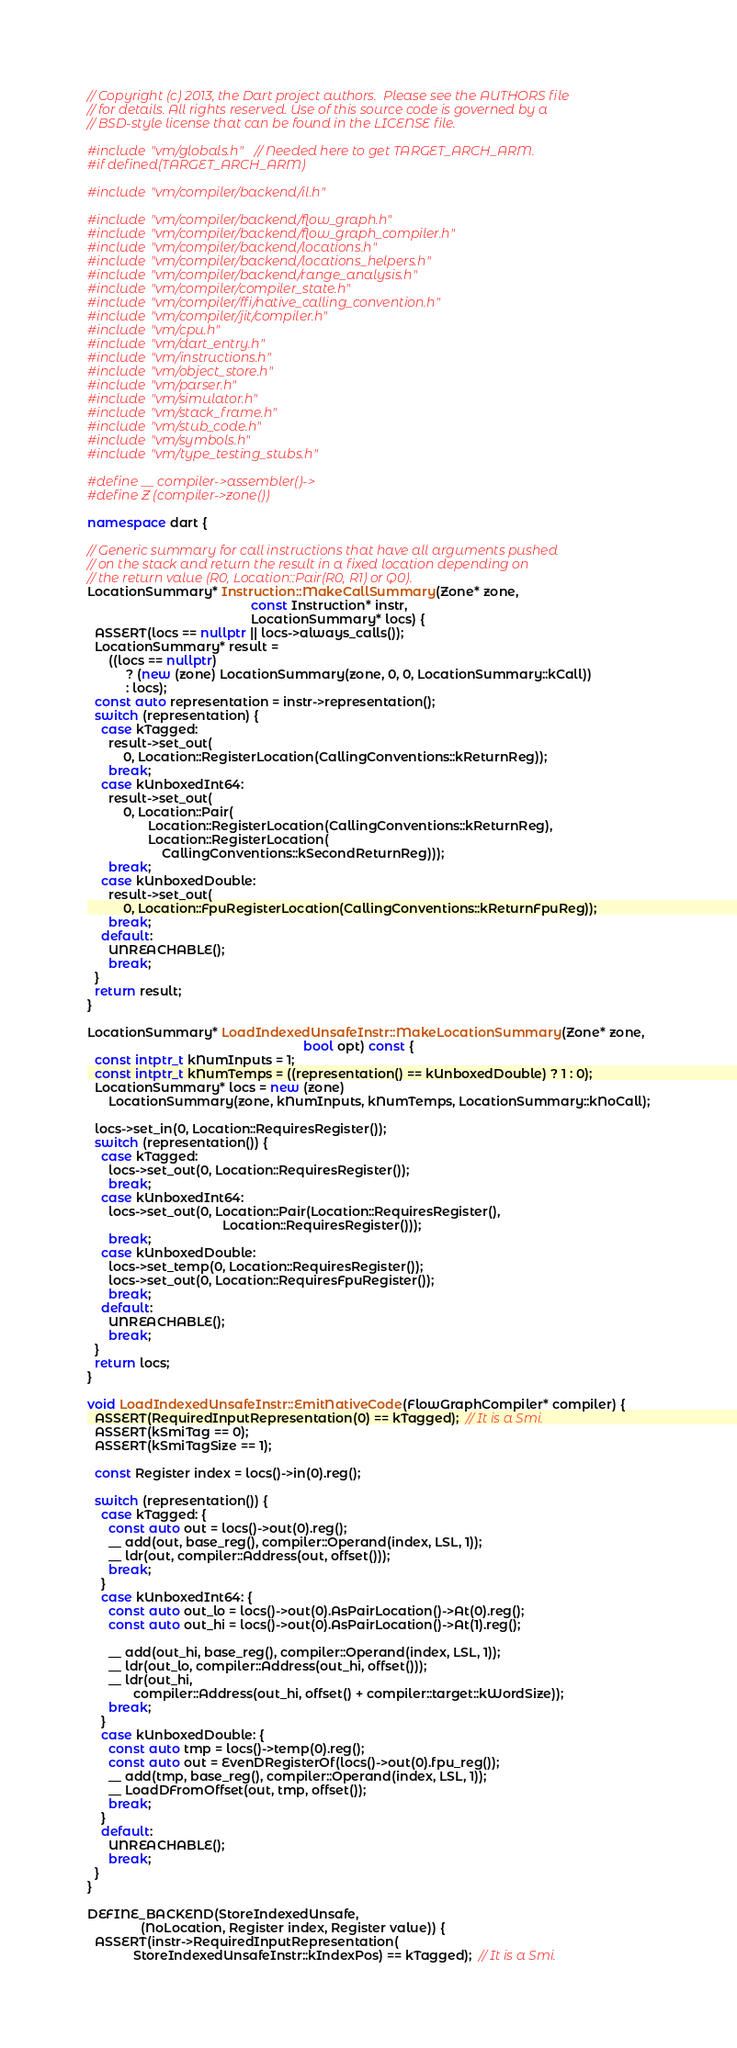<code> <loc_0><loc_0><loc_500><loc_500><_C++_>// Copyright (c) 2013, the Dart project authors.  Please see the AUTHORS file
// for details. All rights reserved. Use of this source code is governed by a
// BSD-style license that can be found in the LICENSE file.

#include "vm/globals.h"  // Needed here to get TARGET_ARCH_ARM.
#if defined(TARGET_ARCH_ARM)

#include "vm/compiler/backend/il.h"

#include "vm/compiler/backend/flow_graph.h"
#include "vm/compiler/backend/flow_graph_compiler.h"
#include "vm/compiler/backend/locations.h"
#include "vm/compiler/backend/locations_helpers.h"
#include "vm/compiler/backend/range_analysis.h"
#include "vm/compiler/compiler_state.h"
#include "vm/compiler/ffi/native_calling_convention.h"
#include "vm/compiler/jit/compiler.h"
#include "vm/cpu.h"
#include "vm/dart_entry.h"
#include "vm/instructions.h"
#include "vm/object_store.h"
#include "vm/parser.h"
#include "vm/simulator.h"
#include "vm/stack_frame.h"
#include "vm/stub_code.h"
#include "vm/symbols.h"
#include "vm/type_testing_stubs.h"

#define __ compiler->assembler()->
#define Z (compiler->zone())

namespace dart {

// Generic summary for call instructions that have all arguments pushed
// on the stack and return the result in a fixed location depending on
// the return value (R0, Location::Pair(R0, R1) or Q0).
LocationSummary* Instruction::MakeCallSummary(Zone* zone,
                                              const Instruction* instr,
                                              LocationSummary* locs) {
  ASSERT(locs == nullptr || locs->always_calls());
  LocationSummary* result =
      ((locs == nullptr)
           ? (new (zone) LocationSummary(zone, 0, 0, LocationSummary::kCall))
           : locs);
  const auto representation = instr->representation();
  switch (representation) {
    case kTagged:
      result->set_out(
          0, Location::RegisterLocation(CallingConventions::kReturnReg));
      break;
    case kUnboxedInt64:
      result->set_out(
          0, Location::Pair(
                 Location::RegisterLocation(CallingConventions::kReturnReg),
                 Location::RegisterLocation(
                     CallingConventions::kSecondReturnReg)));
      break;
    case kUnboxedDouble:
      result->set_out(
          0, Location::FpuRegisterLocation(CallingConventions::kReturnFpuReg));
      break;
    default:
      UNREACHABLE();
      break;
  }
  return result;
}

LocationSummary* LoadIndexedUnsafeInstr::MakeLocationSummary(Zone* zone,
                                                             bool opt) const {
  const intptr_t kNumInputs = 1;
  const intptr_t kNumTemps = ((representation() == kUnboxedDouble) ? 1 : 0);
  LocationSummary* locs = new (zone)
      LocationSummary(zone, kNumInputs, kNumTemps, LocationSummary::kNoCall);

  locs->set_in(0, Location::RequiresRegister());
  switch (representation()) {
    case kTagged:
      locs->set_out(0, Location::RequiresRegister());
      break;
    case kUnboxedInt64:
      locs->set_out(0, Location::Pair(Location::RequiresRegister(),
                                      Location::RequiresRegister()));
      break;
    case kUnboxedDouble:
      locs->set_temp(0, Location::RequiresRegister());
      locs->set_out(0, Location::RequiresFpuRegister());
      break;
    default:
      UNREACHABLE();
      break;
  }
  return locs;
}

void LoadIndexedUnsafeInstr::EmitNativeCode(FlowGraphCompiler* compiler) {
  ASSERT(RequiredInputRepresentation(0) == kTagged);  // It is a Smi.
  ASSERT(kSmiTag == 0);
  ASSERT(kSmiTagSize == 1);

  const Register index = locs()->in(0).reg();

  switch (representation()) {
    case kTagged: {
      const auto out = locs()->out(0).reg();
      __ add(out, base_reg(), compiler::Operand(index, LSL, 1));
      __ ldr(out, compiler::Address(out, offset()));
      break;
    }
    case kUnboxedInt64: {
      const auto out_lo = locs()->out(0).AsPairLocation()->At(0).reg();
      const auto out_hi = locs()->out(0).AsPairLocation()->At(1).reg();

      __ add(out_hi, base_reg(), compiler::Operand(index, LSL, 1));
      __ ldr(out_lo, compiler::Address(out_hi, offset()));
      __ ldr(out_hi,
             compiler::Address(out_hi, offset() + compiler::target::kWordSize));
      break;
    }
    case kUnboxedDouble: {
      const auto tmp = locs()->temp(0).reg();
      const auto out = EvenDRegisterOf(locs()->out(0).fpu_reg());
      __ add(tmp, base_reg(), compiler::Operand(index, LSL, 1));
      __ LoadDFromOffset(out, tmp, offset());
      break;
    }
    default:
      UNREACHABLE();
      break;
  }
}

DEFINE_BACKEND(StoreIndexedUnsafe,
               (NoLocation, Register index, Register value)) {
  ASSERT(instr->RequiredInputRepresentation(
             StoreIndexedUnsafeInstr::kIndexPos) == kTagged);  // It is a Smi.</code> 